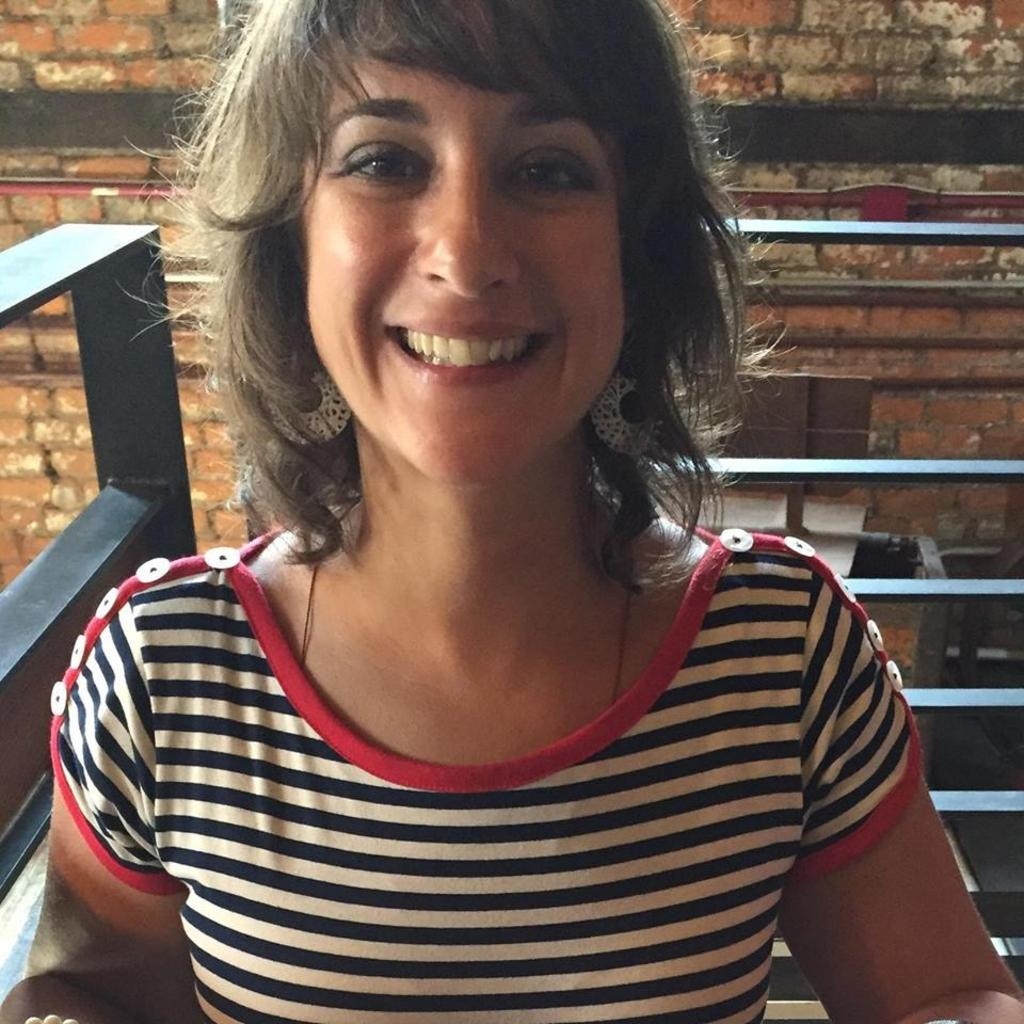Who is the main subject in the image? There is a woman in the center of the image. What can be seen in the background of the image? There is a wall and some objects in the background of the image. What is the texture of the coil in the image? There is no coil present in the image, so we cannot determine its texture. 